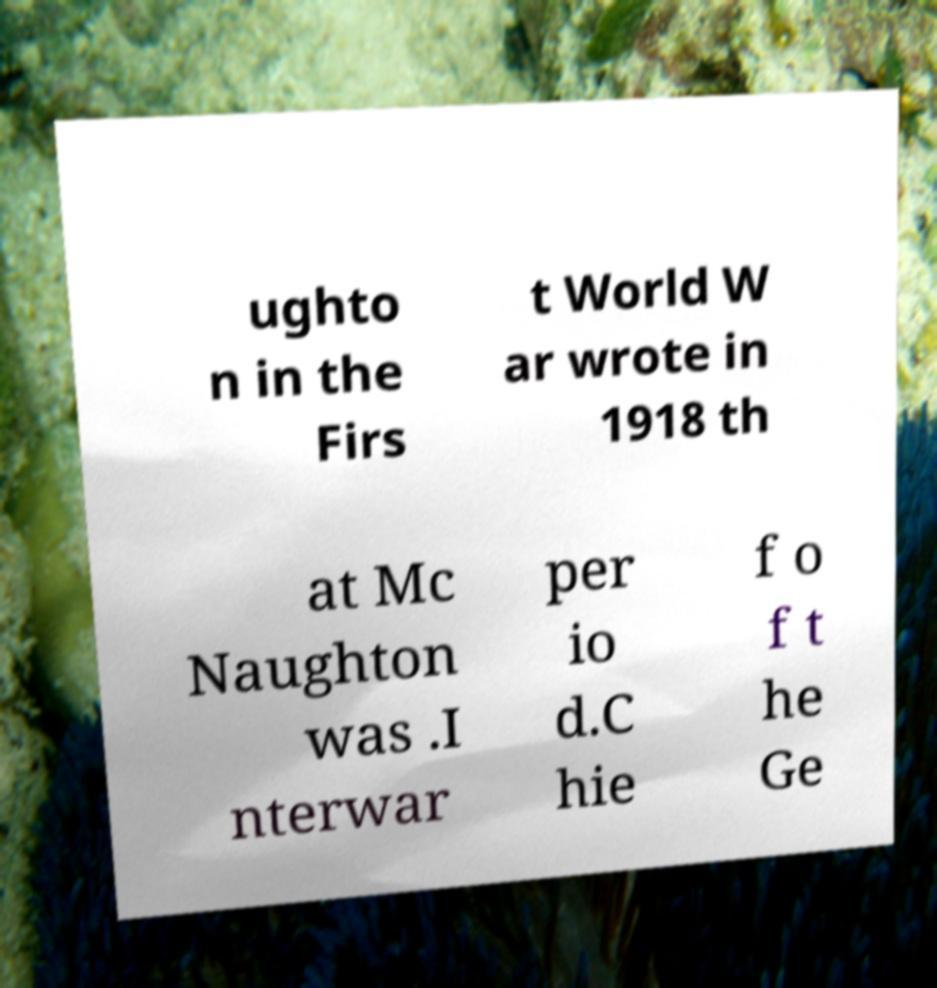What messages or text are displayed in this image? I need them in a readable, typed format. ughto n in the Firs t World W ar wrote in 1918 th at Mc Naughton was .I nterwar per io d.C hie f o f t he Ge 